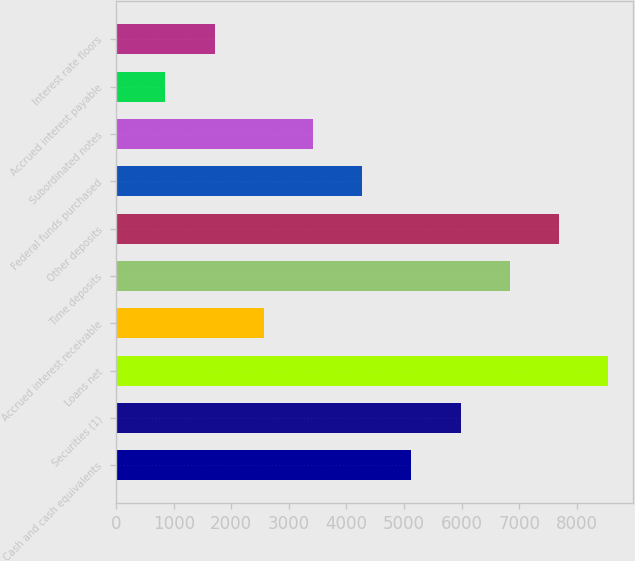<chart> <loc_0><loc_0><loc_500><loc_500><bar_chart><fcel>Cash and cash equivalents<fcel>Securities (1)<fcel>Loans net<fcel>Accrued interest receivable<fcel>Time deposits<fcel>Other deposits<fcel>Federal funds purchased<fcel>Subordinated notes<fcel>Accrued interest payable<fcel>Interest rate floors<nl><fcel>5128.48<fcel>5983.16<fcel>8547.2<fcel>2564.44<fcel>6837.84<fcel>7692.52<fcel>4273.8<fcel>3419.12<fcel>855.08<fcel>1709.76<nl></chart> 